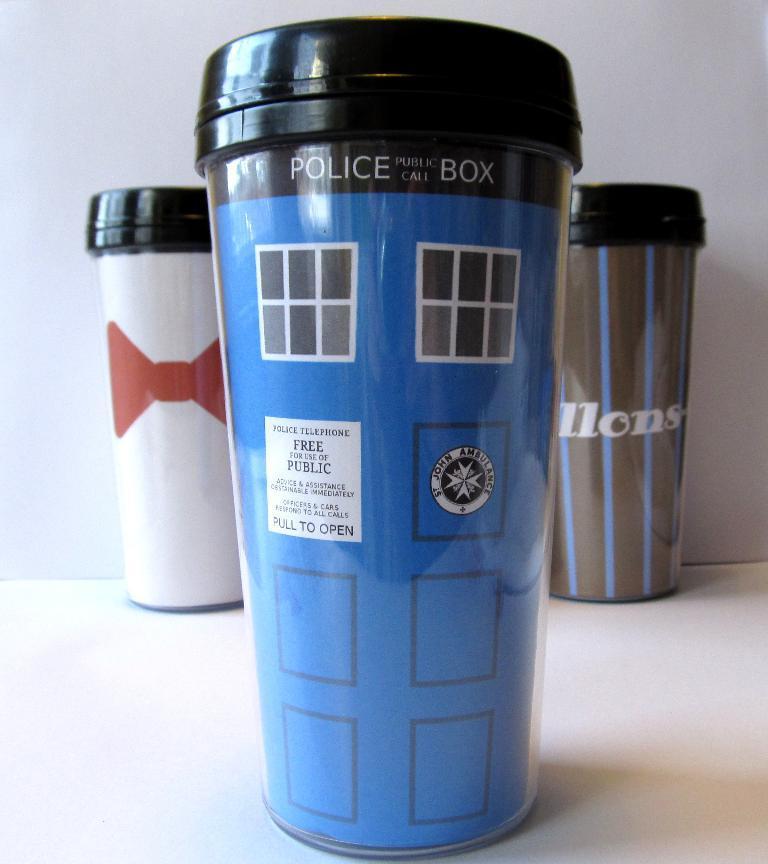Describe this image in one or two sentences. In this image I see 3 bottles in which this one is of black, white and red in color and this one is of black, blue and white in color and this one is of black, blue and brown in color and I see words written on these 2 bottles and I see a logo over here and these 3 bottles are on the white surface and it is white in the background. 